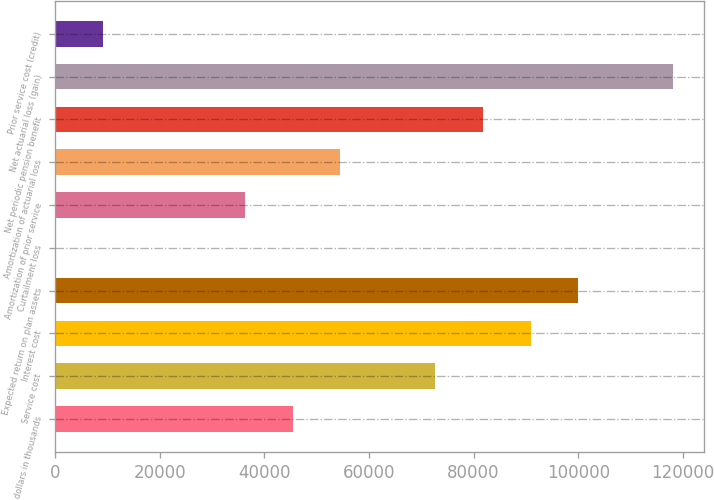Convert chart to OTSL. <chart><loc_0><loc_0><loc_500><loc_500><bar_chart><fcel>dollars in thousands<fcel>Service cost<fcel>Interest cost<fcel>Expected return on plan assets<fcel>Curtailment loss<fcel>Amortization of prior service<fcel>Amortization of actuarial loss<fcel>Net periodic pension benefit<fcel>Net actuarial loss (gain)<fcel>Prior service cost (credit)<nl><fcel>45443.9<fcel>72709.1<fcel>90886<fcel>99974.4<fcel>1.86<fcel>36355.5<fcel>54532.3<fcel>81797.6<fcel>118151<fcel>9090.27<nl></chart> 